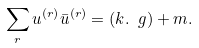Convert formula to latex. <formula><loc_0><loc_0><loc_500><loc_500>\sum _ { r } u ^ { ( r ) } \bar { u } ^ { ( r ) } = ( k . \ g ) + m .</formula> 